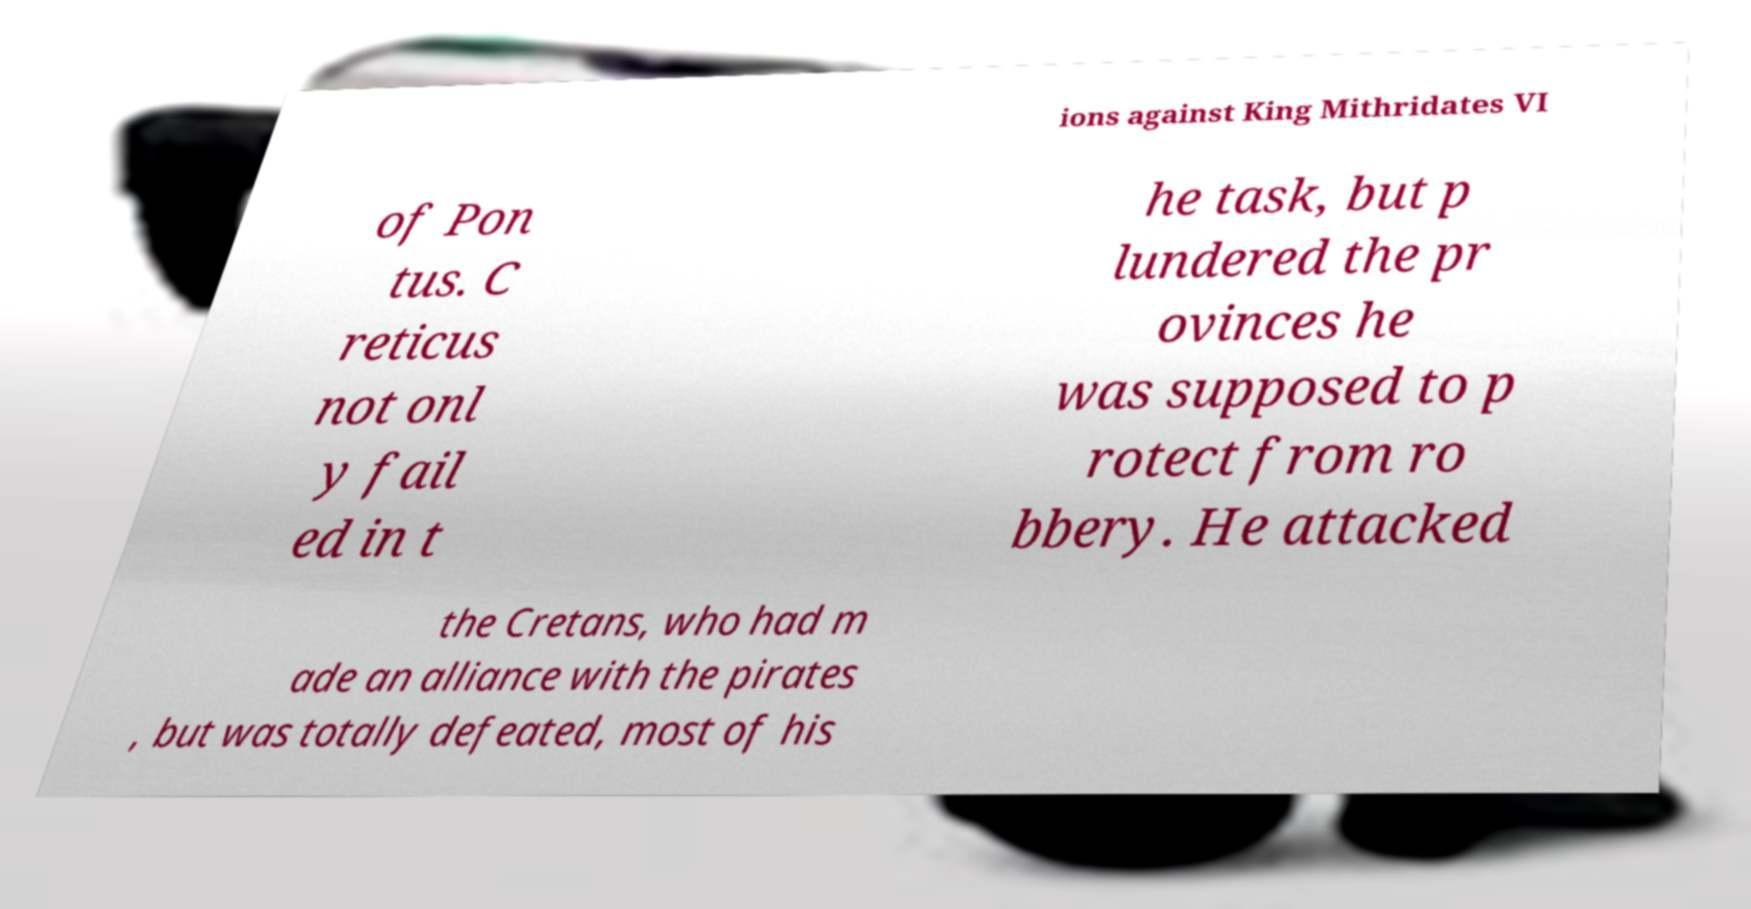Please identify and transcribe the text found in this image. ions against King Mithridates VI of Pon tus. C reticus not onl y fail ed in t he task, but p lundered the pr ovinces he was supposed to p rotect from ro bbery. He attacked the Cretans, who had m ade an alliance with the pirates , but was totally defeated, most of his 